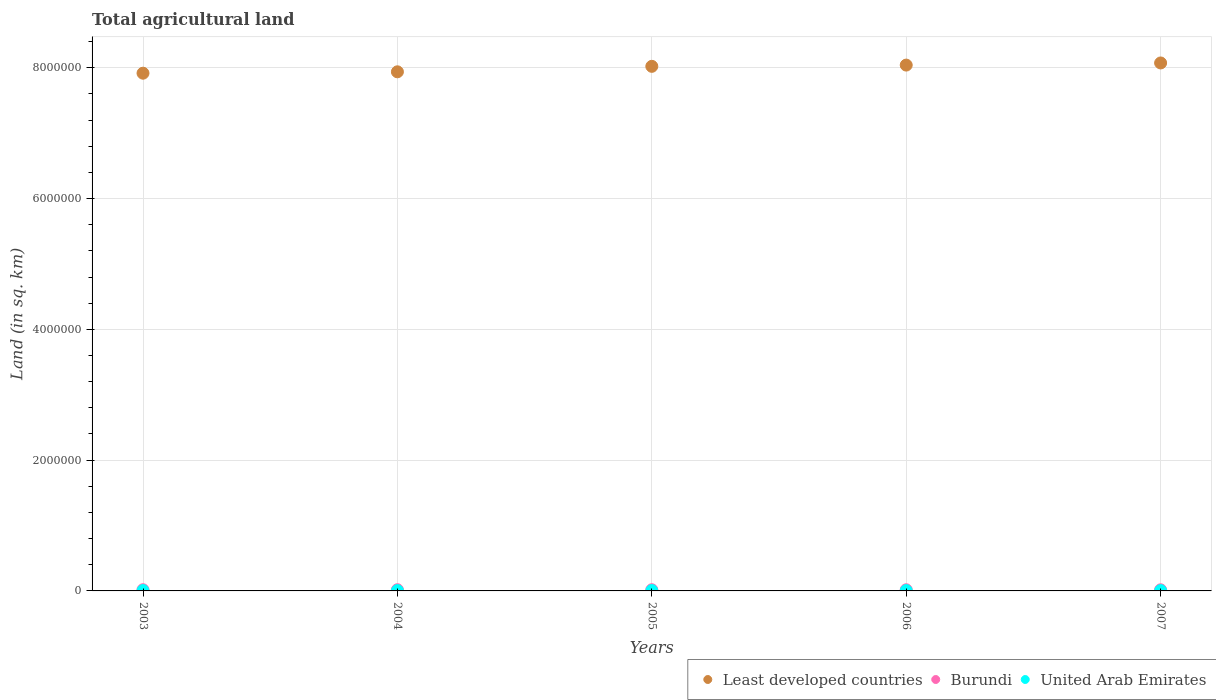What is the total agricultural land in United Arab Emirates in 2004?
Ensure brevity in your answer.  5590. Across all years, what is the maximum total agricultural land in Burundi?
Offer a terse response. 1.85e+04. Across all years, what is the minimum total agricultural land in United Arab Emirates?
Offer a terse response. 5376. In which year was the total agricultural land in United Arab Emirates minimum?
Offer a terse response. 2007. What is the total total agricultural land in United Arab Emirates in the graph?
Your answer should be compact. 2.76e+04. What is the difference between the total agricultural land in Least developed countries in 2003 and that in 2004?
Your response must be concise. -2.13e+04. What is the difference between the total agricultural land in Burundi in 2004 and the total agricultural land in Least developed countries in 2003?
Offer a very short reply. -7.90e+06. What is the average total agricultural land in Burundi per year?
Your answer should be compact. 1.80e+04. In the year 2005, what is the difference between the total agricultural land in Least developed countries and total agricultural land in United Arab Emirates?
Ensure brevity in your answer.  8.02e+06. In how many years, is the total agricultural land in Least developed countries greater than 6000000 sq.km?
Your response must be concise. 5. What is the ratio of the total agricultural land in United Arab Emirates in 2006 to that in 2007?
Provide a short and direct response. 1.01. Is the total agricultural land in Least developed countries in 2003 less than that in 2006?
Offer a very short reply. Yes. Is the difference between the total agricultural land in Least developed countries in 2005 and 2006 greater than the difference between the total agricultural land in United Arab Emirates in 2005 and 2006?
Your answer should be compact. No. What is the difference between the highest and the second highest total agricultural land in United Arab Emirates?
Provide a short and direct response. 30. What is the difference between the highest and the lowest total agricultural land in United Arab Emirates?
Keep it short and to the point. 244. Is the sum of the total agricultural land in United Arab Emirates in 2003 and 2006 greater than the maximum total agricultural land in Burundi across all years?
Your answer should be compact. No. Does the total agricultural land in Least developed countries monotonically increase over the years?
Make the answer very short. Yes. Is the total agricultural land in Burundi strictly greater than the total agricultural land in Least developed countries over the years?
Provide a succinct answer. No. Is the total agricultural land in Least developed countries strictly less than the total agricultural land in United Arab Emirates over the years?
Give a very brief answer. No. How many dotlines are there?
Your answer should be very brief. 3. How many years are there in the graph?
Your response must be concise. 5. Does the graph contain grids?
Ensure brevity in your answer.  Yes. How many legend labels are there?
Offer a terse response. 3. How are the legend labels stacked?
Your answer should be compact. Horizontal. What is the title of the graph?
Your response must be concise. Total agricultural land. Does "Nicaragua" appear as one of the legend labels in the graph?
Offer a terse response. No. What is the label or title of the X-axis?
Offer a terse response. Years. What is the label or title of the Y-axis?
Ensure brevity in your answer.  Land (in sq. km). What is the Land (in sq. km) of Least developed countries in 2003?
Offer a terse response. 7.92e+06. What is the Land (in sq. km) of Burundi in 2003?
Make the answer very short. 1.83e+04. What is the Land (in sq. km) of United Arab Emirates in 2003?
Provide a succinct answer. 5590. What is the Land (in sq. km) in Least developed countries in 2004?
Offer a terse response. 7.94e+06. What is the Land (in sq. km) of Burundi in 2004?
Your answer should be compact. 1.85e+04. What is the Land (in sq. km) of United Arab Emirates in 2004?
Provide a short and direct response. 5590. What is the Land (in sq. km) in Least developed countries in 2005?
Provide a succinct answer. 8.02e+06. What is the Land (in sq. km) in Burundi in 2005?
Your answer should be very brief. 1.82e+04. What is the Land (in sq. km) in United Arab Emirates in 2005?
Provide a succinct answer. 5620. What is the Land (in sq. km) of Least developed countries in 2006?
Provide a succinct answer. 8.04e+06. What is the Land (in sq. km) in Burundi in 2006?
Your answer should be compact. 1.78e+04. What is the Land (in sq. km) of United Arab Emirates in 2006?
Your response must be concise. 5436. What is the Land (in sq. km) of Least developed countries in 2007?
Your answer should be very brief. 8.07e+06. What is the Land (in sq. km) in Burundi in 2007?
Give a very brief answer. 1.73e+04. What is the Land (in sq. km) in United Arab Emirates in 2007?
Give a very brief answer. 5376. Across all years, what is the maximum Land (in sq. km) in Least developed countries?
Your response must be concise. 8.07e+06. Across all years, what is the maximum Land (in sq. km) in Burundi?
Offer a very short reply. 1.85e+04. Across all years, what is the maximum Land (in sq. km) in United Arab Emirates?
Offer a very short reply. 5620. Across all years, what is the minimum Land (in sq. km) in Least developed countries?
Your response must be concise. 7.92e+06. Across all years, what is the minimum Land (in sq. km) of Burundi?
Your response must be concise. 1.73e+04. Across all years, what is the minimum Land (in sq. km) of United Arab Emirates?
Keep it short and to the point. 5376. What is the total Land (in sq. km) in Least developed countries in the graph?
Your response must be concise. 4.00e+07. What is the total Land (in sq. km) in Burundi in the graph?
Give a very brief answer. 9.02e+04. What is the total Land (in sq. km) of United Arab Emirates in the graph?
Make the answer very short. 2.76e+04. What is the difference between the Land (in sq. km) in Least developed countries in 2003 and that in 2004?
Your response must be concise. -2.13e+04. What is the difference between the Land (in sq. km) of Burundi in 2003 and that in 2004?
Offer a terse response. -150. What is the difference between the Land (in sq. km) in United Arab Emirates in 2003 and that in 2004?
Give a very brief answer. 0. What is the difference between the Land (in sq. km) in Least developed countries in 2003 and that in 2005?
Your answer should be compact. -1.05e+05. What is the difference between the Land (in sq. km) of Burundi in 2003 and that in 2005?
Your response must be concise. 140. What is the difference between the Land (in sq. km) of Least developed countries in 2003 and that in 2006?
Keep it short and to the point. -1.24e+05. What is the difference between the Land (in sq. km) of Burundi in 2003 and that in 2006?
Provide a succinct answer. 500. What is the difference between the Land (in sq. km) in United Arab Emirates in 2003 and that in 2006?
Your answer should be very brief. 154. What is the difference between the Land (in sq. km) in Least developed countries in 2003 and that in 2007?
Ensure brevity in your answer.  -1.57e+05. What is the difference between the Land (in sq. km) of United Arab Emirates in 2003 and that in 2007?
Your answer should be compact. 214. What is the difference between the Land (in sq. km) in Least developed countries in 2004 and that in 2005?
Provide a succinct answer. -8.37e+04. What is the difference between the Land (in sq. km) in Burundi in 2004 and that in 2005?
Offer a terse response. 290. What is the difference between the Land (in sq. km) of United Arab Emirates in 2004 and that in 2005?
Keep it short and to the point. -30. What is the difference between the Land (in sq. km) of Least developed countries in 2004 and that in 2006?
Make the answer very short. -1.03e+05. What is the difference between the Land (in sq. km) in Burundi in 2004 and that in 2006?
Your answer should be compact. 650. What is the difference between the Land (in sq. km) of United Arab Emirates in 2004 and that in 2006?
Your answer should be compact. 154. What is the difference between the Land (in sq. km) of Least developed countries in 2004 and that in 2007?
Make the answer very short. -1.35e+05. What is the difference between the Land (in sq. km) of Burundi in 2004 and that in 2007?
Give a very brief answer. 1150. What is the difference between the Land (in sq. km) in United Arab Emirates in 2004 and that in 2007?
Your response must be concise. 214. What is the difference between the Land (in sq. km) of Least developed countries in 2005 and that in 2006?
Your answer should be very brief. -1.90e+04. What is the difference between the Land (in sq. km) in Burundi in 2005 and that in 2006?
Offer a terse response. 360. What is the difference between the Land (in sq. km) in United Arab Emirates in 2005 and that in 2006?
Provide a short and direct response. 184. What is the difference between the Land (in sq. km) in Least developed countries in 2005 and that in 2007?
Your response must be concise. -5.17e+04. What is the difference between the Land (in sq. km) in Burundi in 2005 and that in 2007?
Provide a succinct answer. 860. What is the difference between the Land (in sq. km) of United Arab Emirates in 2005 and that in 2007?
Your answer should be very brief. 244. What is the difference between the Land (in sq. km) of Least developed countries in 2006 and that in 2007?
Give a very brief answer. -3.27e+04. What is the difference between the Land (in sq. km) of Burundi in 2006 and that in 2007?
Your answer should be very brief. 500. What is the difference between the Land (in sq. km) of Least developed countries in 2003 and the Land (in sq. km) of Burundi in 2004?
Make the answer very short. 7.90e+06. What is the difference between the Land (in sq. km) of Least developed countries in 2003 and the Land (in sq. km) of United Arab Emirates in 2004?
Offer a terse response. 7.91e+06. What is the difference between the Land (in sq. km) of Burundi in 2003 and the Land (in sq. km) of United Arab Emirates in 2004?
Provide a short and direct response. 1.27e+04. What is the difference between the Land (in sq. km) of Least developed countries in 2003 and the Land (in sq. km) of Burundi in 2005?
Your answer should be very brief. 7.90e+06. What is the difference between the Land (in sq. km) of Least developed countries in 2003 and the Land (in sq. km) of United Arab Emirates in 2005?
Make the answer very short. 7.91e+06. What is the difference between the Land (in sq. km) of Burundi in 2003 and the Land (in sq. km) of United Arab Emirates in 2005?
Your response must be concise. 1.27e+04. What is the difference between the Land (in sq. km) of Least developed countries in 2003 and the Land (in sq. km) of Burundi in 2006?
Provide a short and direct response. 7.90e+06. What is the difference between the Land (in sq. km) in Least developed countries in 2003 and the Land (in sq. km) in United Arab Emirates in 2006?
Your answer should be compact. 7.91e+06. What is the difference between the Land (in sq. km) in Burundi in 2003 and the Land (in sq. km) in United Arab Emirates in 2006?
Your response must be concise. 1.29e+04. What is the difference between the Land (in sq. km) in Least developed countries in 2003 and the Land (in sq. km) in Burundi in 2007?
Provide a short and direct response. 7.90e+06. What is the difference between the Land (in sq. km) of Least developed countries in 2003 and the Land (in sq. km) of United Arab Emirates in 2007?
Give a very brief answer. 7.91e+06. What is the difference between the Land (in sq. km) in Burundi in 2003 and the Land (in sq. km) in United Arab Emirates in 2007?
Provide a succinct answer. 1.30e+04. What is the difference between the Land (in sq. km) of Least developed countries in 2004 and the Land (in sq. km) of Burundi in 2005?
Ensure brevity in your answer.  7.92e+06. What is the difference between the Land (in sq. km) of Least developed countries in 2004 and the Land (in sq. km) of United Arab Emirates in 2005?
Offer a terse response. 7.93e+06. What is the difference between the Land (in sq. km) in Burundi in 2004 and the Land (in sq. km) in United Arab Emirates in 2005?
Your answer should be compact. 1.29e+04. What is the difference between the Land (in sq. km) of Least developed countries in 2004 and the Land (in sq. km) of Burundi in 2006?
Your response must be concise. 7.92e+06. What is the difference between the Land (in sq. km) of Least developed countries in 2004 and the Land (in sq. km) of United Arab Emirates in 2006?
Your response must be concise. 7.93e+06. What is the difference between the Land (in sq. km) of Burundi in 2004 and the Land (in sq. km) of United Arab Emirates in 2006?
Offer a terse response. 1.30e+04. What is the difference between the Land (in sq. km) in Least developed countries in 2004 and the Land (in sq. km) in Burundi in 2007?
Your answer should be compact. 7.92e+06. What is the difference between the Land (in sq. km) of Least developed countries in 2004 and the Land (in sq. km) of United Arab Emirates in 2007?
Provide a short and direct response. 7.93e+06. What is the difference between the Land (in sq. km) in Burundi in 2004 and the Land (in sq. km) in United Arab Emirates in 2007?
Your answer should be compact. 1.31e+04. What is the difference between the Land (in sq. km) in Least developed countries in 2005 and the Land (in sq. km) in Burundi in 2006?
Offer a very short reply. 8.00e+06. What is the difference between the Land (in sq. km) in Least developed countries in 2005 and the Land (in sq. km) in United Arab Emirates in 2006?
Your answer should be compact. 8.02e+06. What is the difference between the Land (in sq. km) of Burundi in 2005 and the Land (in sq. km) of United Arab Emirates in 2006?
Your response must be concise. 1.28e+04. What is the difference between the Land (in sq. km) in Least developed countries in 2005 and the Land (in sq. km) in Burundi in 2007?
Ensure brevity in your answer.  8.00e+06. What is the difference between the Land (in sq. km) in Least developed countries in 2005 and the Land (in sq. km) in United Arab Emirates in 2007?
Offer a terse response. 8.02e+06. What is the difference between the Land (in sq. km) in Burundi in 2005 and the Land (in sq. km) in United Arab Emirates in 2007?
Your response must be concise. 1.28e+04. What is the difference between the Land (in sq. km) of Least developed countries in 2006 and the Land (in sq. km) of Burundi in 2007?
Your response must be concise. 8.02e+06. What is the difference between the Land (in sq. km) in Least developed countries in 2006 and the Land (in sq. km) in United Arab Emirates in 2007?
Your answer should be very brief. 8.04e+06. What is the difference between the Land (in sq. km) in Burundi in 2006 and the Land (in sq. km) in United Arab Emirates in 2007?
Make the answer very short. 1.25e+04. What is the average Land (in sq. km) in Least developed countries per year?
Your response must be concise. 8.00e+06. What is the average Land (in sq. km) of Burundi per year?
Make the answer very short. 1.80e+04. What is the average Land (in sq. km) in United Arab Emirates per year?
Keep it short and to the point. 5522.4. In the year 2003, what is the difference between the Land (in sq. km) in Least developed countries and Land (in sq. km) in Burundi?
Keep it short and to the point. 7.90e+06. In the year 2003, what is the difference between the Land (in sq. km) of Least developed countries and Land (in sq. km) of United Arab Emirates?
Offer a terse response. 7.91e+06. In the year 2003, what is the difference between the Land (in sq. km) in Burundi and Land (in sq. km) in United Arab Emirates?
Offer a terse response. 1.27e+04. In the year 2004, what is the difference between the Land (in sq. km) in Least developed countries and Land (in sq. km) in Burundi?
Your response must be concise. 7.92e+06. In the year 2004, what is the difference between the Land (in sq. km) of Least developed countries and Land (in sq. km) of United Arab Emirates?
Provide a succinct answer. 7.93e+06. In the year 2004, what is the difference between the Land (in sq. km) in Burundi and Land (in sq. km) in United Arab Emirates?
Provide a short and direct response. 1.29e+04. In the year 2005, what is the difference between the Land (in sq. km) in Least developed countries and Land (in sq. km) in Burundi?
Ensure brevity in your answer.  8.00e+06. In the year 2005, what is the difference between the Land (in sq. km) of Least developed countries and Land (in sq. km) of United Arab Emirates?
Ensure brevity in your answer.  8.02e+06. In the year 2005, what is the difference between the Land (in sq. km) in Burundi and Land (in sq. km) in United Arab Emirates?
Provide a short and direct response. 1.26e+04. In the year 2006, what is the difference between the Land (in sq. km) in Least developed countries and Land (in sq. km) in Burundi?
Give a very brief answer. 8.02e+06. In the year 2006, what is the difference between the Land (in sq. km) of Least developed countries and Land (in sq. km) of United Arab Emirates?
Your answer should be very brief. 8.04e+06. In the year 2006, what is the difference between the Land (in sq. km) of Burundi and Land (in sq. km) of United Arab Emirates?
Offer a terse response. 1.24e+04. In the year 2007, what is the difference between the Land (in sq. km) of Least developed countries and Land (in sq. km) of Burundi?
Provide a succinct answer. 8.06e+06. In the year 2007, what is the difference between the Land (in sq. km) in Least developed countries and Land (in sq. km) in United Arab Emirates?
Make the answer very short. 8.07e+06. In the year 2007, what is the difference between the Land (in sq. km) in Burundi and Land (in sq. km) in United Arab Emirates?
Give a very brief answer. 1.20e+04. What is the ratio of the Land (in sq. km) in Least developed countries in 2003 to that in 2004?
Your response must be concise. 1. What is the ratio of the Land (in sq. km) in United Arab Emirates in 2003 to that in 2004?
Keep it short and to the point. 1. What is the ratio of the Land (in sq. km) of Least developed countries in 2003 to that in 2005?
Offer a terse response. 0.99. What is the ratio of the Land (in sq. km) of Burundi in 2003 to that in 2005?
Ensure brevity in your answer.  1.01. What is the ratio of the Land (in sq. km) of Least developed countries in 2003 to that in 2006?
Offer a terse response. 0.98. What is the ratio of the Land (in sq. km) in Burundi in 2003 to that in 2006?
Offer a terse response. 1.03. What is the ratio of the Land (in sq. km) of United Arab Emirates in 2003 to that in 2006?
Offer a terse response. 1.03. What is the ratio of the Land (in sq. km) of Least developed countries in 2003 to that in 2007?
Make the answer very short. 0.98. What is the ratio of the Land (in sq. km) of Burundi in 2003 to that in 2007?
Your response must be concise. 1.06. What is the ratio of the Land (in sq. km) in United Arab Emirates in 2003 to that in 2007?
Your answer should be compact. 1.04. What is the ratio of the Land (in sq. km) of Burundi in 2004 to that in 2005?
Offer a very short reply. 1.02. What is the ratio of the Land (in sq. km) of United Arab Emirates in 2004 to that in 2005?
Your answer should be compact. 0.99. What is the ratio of the Land (in sq. km) in Least developed countries in 2004 to that in 2006?
Provide a short and direct response. 0.99. What is the ratio of the Land (in sq. km) in Burundi in 2004 to that in 2006?
Your response must be concise. 1.04. What is the ratio of the Land (in sq. km) of United Arab Emirates in 2004 to that in 2006?
Keep it short and to the point. 1.03. What is the ratio of the Land (in sq. km) in Least developed countries in 2004 to that in 2007?
Offer a very short reply. 0.98. What is the ratio of the Land (in sq. km) of Burundi in 2004 to that in 2007?
Give a very brief answer. 1.07. What is the ratio of the Land (in sq. km) of United Arab Emirates in 2004 to that in 2007?
Your answer should be very brief. 1.04. What is the ratio of the Land (in sq. km) in Burundi in 2005 to that in 2006?
Ensure brevity in your answer.  1.02. What is the ratio of the Land (in sq. km) of United Arab Emirates in 2005 to that in 2006?
Give a very brief answer. 1.03. What is the ratio of the Land (in sq. km) of Burundi in 2005 to that in 2007?
Make the answer very short. 1.05. What is the ratio of the Land (in sq. km) in United Arab Emirates in 2005 to that in 2007?
Offer a very short reply. 1.05. What is the ratio of the Land (in sq. km) of Burundi in 2006 to that in 2007?
Offer a very short reply. 1.03. What is the ratio of the Land (in sq. km) in United Arab Emirates in 2006 to that in 2007?
Keep it short and to the point. 1.01. What is the difference between the highest and the second highest Land (in sq. km) of Least developed countries?
Provide a succinct answer. 3.27e+04. What is the difference between the highest and the second highest Land (in sq. km) of Burundi?
Provide a succinct answer. 150. What is the difference between the highest and the lowest Land (in sq. km) of Least developed countries?
Provide a short and direct response. 1.57e+05. What is the difference between the highest and the lowest Land (in sq. km) of Burundi?
Your answer should be compact. 1150. What is the difference between the highest and the lowest Land (in sq. km) of United Arab Emirates?
Provide a succinct answer. 244. 